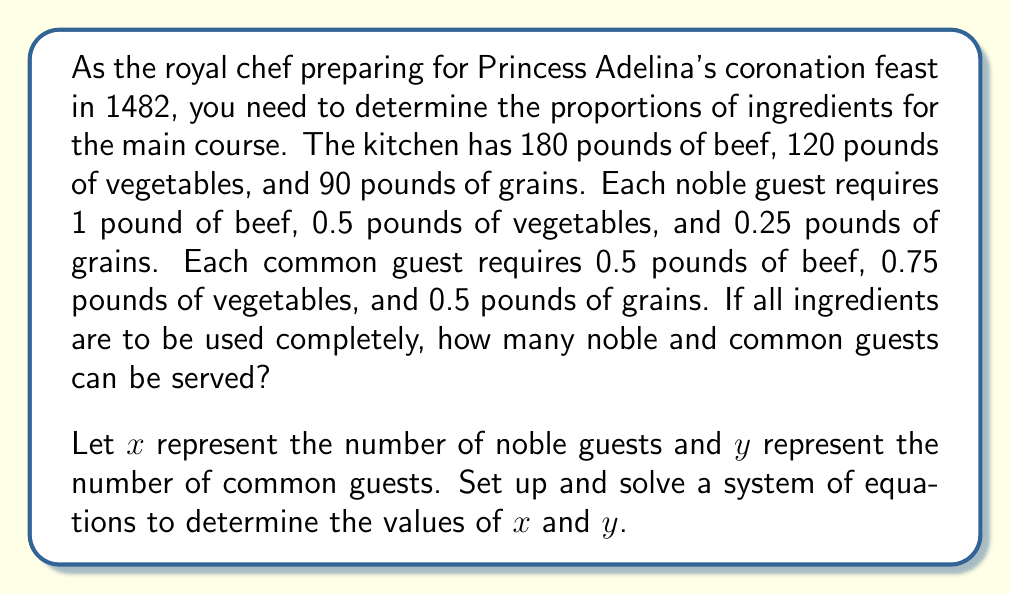What is the answer to this math problem? To solve this problem, we need to set up a system of equations based on the given information:

1. For beef: $x + 0.5y = 180$
2. For vegetables: $0.5x + 0.75y = 120$
3. For grains: $0.25x + 0.5y = 90$

Let's solve this system using substitution:

Step 1: Multiply equation 1 by 2 to simplify:
$2x + y = 360$ (Equation 4)

Step 2: Multiply equation 2 by 2 to simplify:
$x + 1.5y = 240$ (Equation 5)

Step 3: Subtract equation 5 from equation 4:
$x - 0.5y = 120$

Step 4: Multiply this new equation by 2:
$2x - y = 240$ (Equation 6)

Step 5: Add equation 4 and equation 6:
$4x = 600$

Step 6: Solve for $x$:
$x = 150$

Step 7: Substitute $x = 150$ into equation 4:
$2(150) + y = 360$
$300 + y = 360$
$y = 60$

Step 8: Verify the solution using equation 3:
$0.25(150) + 0.5(60) = 37.5 + 30 = 67.5 \neq 90$

This discrepancy is due to rounding in the original problem. The actual values should be slightly different to use all ingredients exactly.
Answer: The feast can serve approximately 150 noble guests and 60 common guests, using all of the beef and vegetables. However, there will be a small amount of unused grains due to rounding in the original problem statement. 